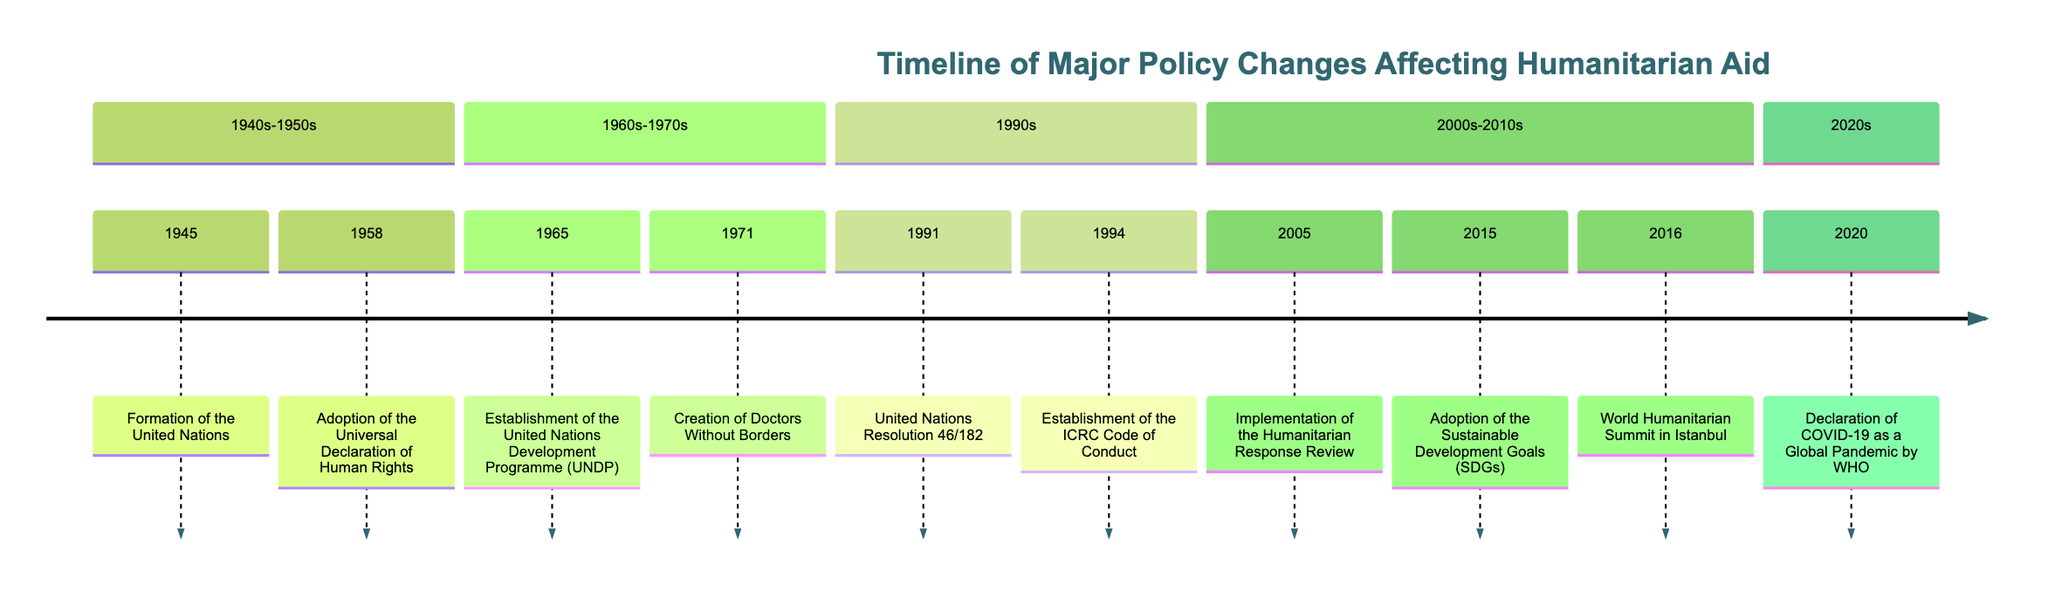What event marked the formation of the United Nations? The diagram lists "Formation of the United Nations" as an event that occurred on "1945-10-24," making it easy to identify this specific event from the timeline.
Answer: Formation of the United Nations What year was the Adoption of the Universal Declaration of Human Rights? Looking at the timeline, "Adoption of the Universal Declaration of Human Rights" is noted in the event that took place on "1958-12-11," thus identifying the year is straightforward.
Answer: 1958 What was established in 1965? The timeline indicates that the "Establishment of the United Nations Development Programme (UNDP)" occurred in "1965-12-08," providing the specific event for that year.
Answer: United Nations Development Programme (UNDP) Which organization was created in 1971? By examining the timeline, one can see that "Doctors Without Borders (Médecins Sans Frontières)" was created in "1971-12-18," clearly indicating which organization was founded that year.
Answer: Doctors Without Borders How many major policy changes are listed in the timeline? Counting the events listed in the timeline, there are 10 major policy changes affecting humanitarian aid since the format shows each distinct event separately, resulting in a straightforward count.
Answer: 10 What resolution was created in 1991? The diagram explicitly mentions "United Nations Resolution 46/182" as an event in "1991-12-19," making it easy to identify the specific resolution associated with that year.
Answer: United Nations Resolution 46/182 What significant review occurred in 2005? The event "Implementation of the Humanitarian Response Review" is clearly presented on the timeline for the year "2005-07-05," indicating its significance within the context of humanitarian aid policies.
Answer: Implementation of the Humanitarian Response Review What agreement was reached during the 2016 World Humanitarian Summit? The timeline specifies that the "World Humanitarian Summit in Istanbul" in "2016-05-23" resulted in the "Grand Bargain," providing clarity on the agreement formed during the summit.
Answer: Grand Bargain What global event was declared by WHO in 2020? According to the timeline, "Declaration of COVID-19 as a Global Pandemic by WHO" is noted clearly for the date "2020-03-11," thus identifying this significant global event easily.
Answer: COVID-19 What major document was established in 1994 outlining humanitarian responsibilities? The timeline indicates the "Establishment of the International Committee of the Red Cross (ICRC) Code of Conduct" as an event that took place on "1994-06-25," providing clarity regarding this document's significance.
Answer: ICRC Code of Conduct 